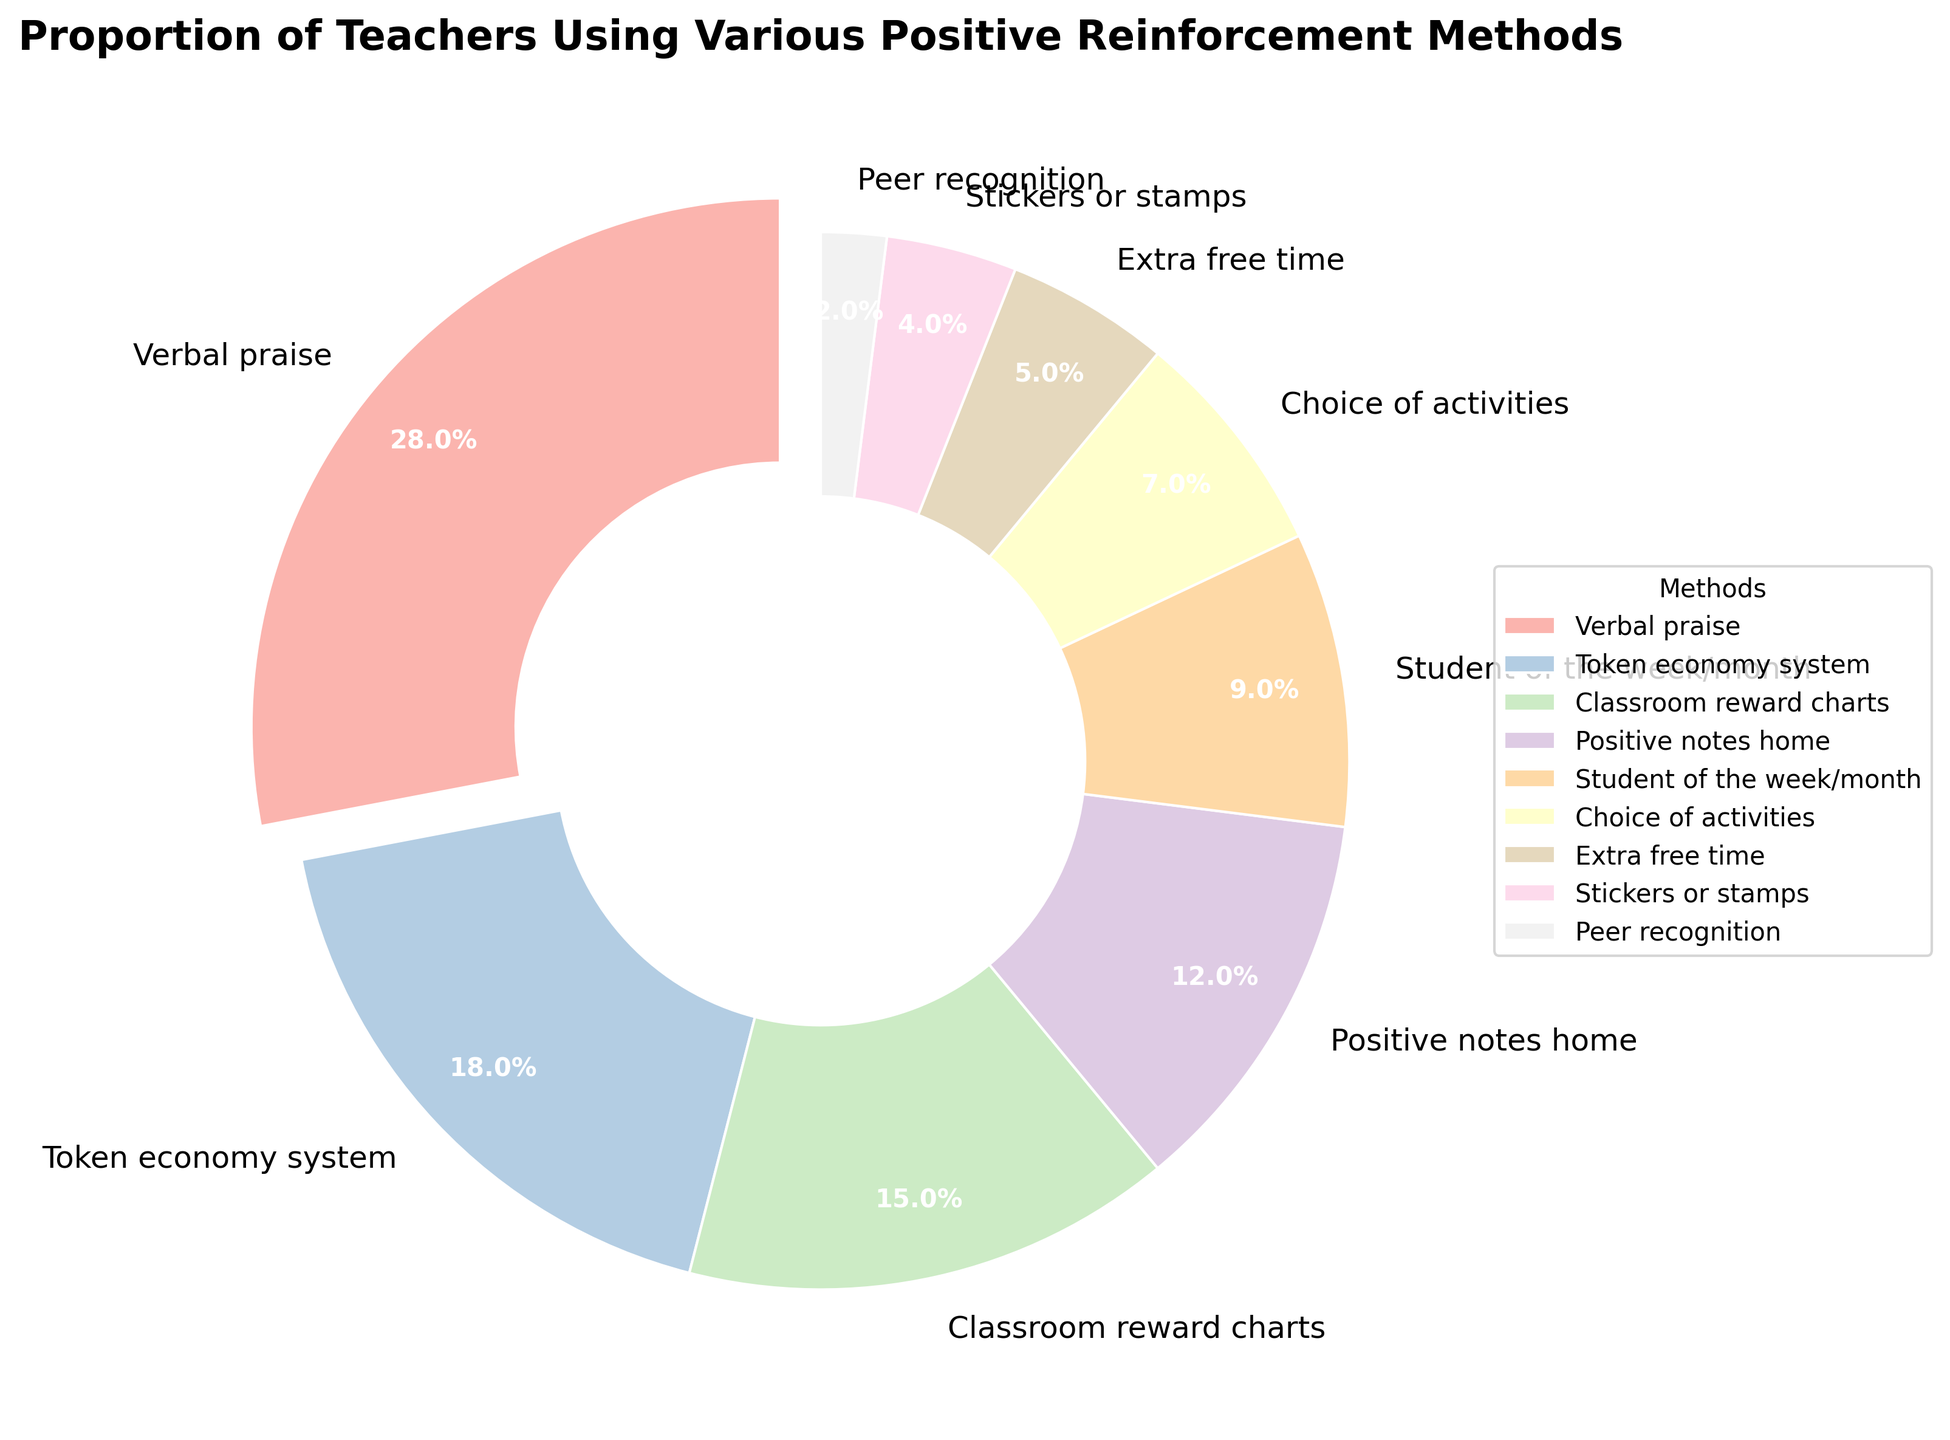What proportion of teachers use verbal praise? The figure shows that 28% of teachers use verbal praise.
Answer: 28% Which positive reinforcement method is used by the fewest number of teachers? The figure shows that peer recognition is used by the fewest number of teachers, with a proportion of 2%.
Answer: Peer recognition What is the total percentage of teachers using either token economy system or classroom reward charts? The figure shows that 18% use a token economy system and 15% use classroom reward charts. Adding these together: 18% + 15% = 33%.
Answer: 33% Is the proportion of teachers using positive notes home greater than those using student of the week/month? The figure indicates that 12% use positive notes home and 9% use student of the week/month. Since 12% is greater than 9%, yes, the proportion is greater.
Answer: Yes How much more frequently is verbal praise used compared to stickers or stamps? The figure shows verbal praise is used by 28% of teachers, while stickers or stamps are used by 4%. Subtracting these values: 28% - 4% = 24%.
Answer: 24% Which method has the second-largest proportion among the teachers? According to the figure, token economy system is used by 18% of teachers, making it the second-largest after verbal praise.
Answer: Token economy system What is the combined proportion of teachers using choice of activities and extra free time? The figure shows that 7% use choice of activities and 5% use extra free time. Adding these together: 7% + 5% = 12%.
Answer: 12% How much more common is verbal praise compared to the sum of peer recognition and stickers or stamps? The figure indicates verbal praise is 28%, peer recognition is 2%, and stickers or stamps are 4%. Summing peer recognition and stickers or stamps: 2% + 4% = 6%. Subtracting from verbal praise: 28% - 6% = 22%.
Answer: 22% What is the difference in percentage between teachers using classroom reward charts and those using student of the week/month? The figure shows classroom reward charts at 15% and student of the week/month at 9%. Subtracting these values: 15% - 9% = 6%.
Answer: 6% 